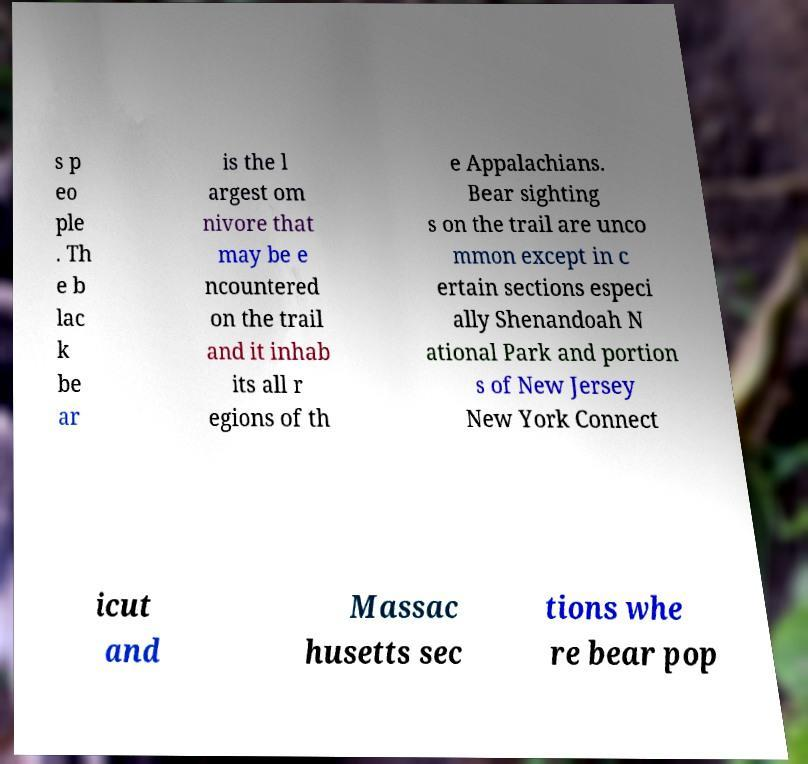Please identify and transcribe the text found in this image. s p eo ple . Th e b lac k be ar is the l argest om nivore that may be e ncountered on the trail and it inhab its all r egions of th e Appalachians. Bear sighting s on the trail are unco mmon except in c ertain sections especi ally Shenandoah N ational Park and portion s of New Jersey New York Connect icut and Massac husetts sec tions whe re bear pop 